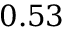Convert formula to latex. <formula><loc_0><loc_0><loc_500><loc_500>0 . 5 3</formula> 